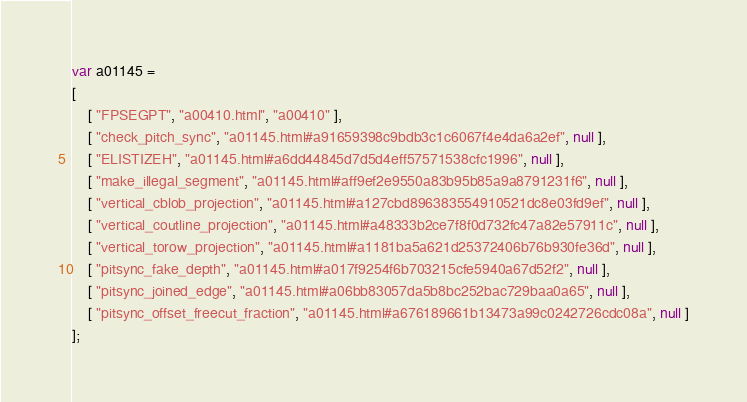Convert code to text. <code><loc_0><loc_0><loc_500><loc_500><_JavaScript_>var a01145 =
[
    [ "FPSEGPT", "a00410.html", "a00410" ],
    [ "check_pitch_sync", "a01145.html#a91659398c9bdb3c1c6067f4e4da6a2ef", null ],
    [ "ELISTIZEH", "a01145.html#a6dd44845d7d5d4eff57571538cfc1996", null ],
    [ "make_illegal_segment", "a01145.html#aff9ef2e9550a83b95b85a9a8791231f6", null ],
    [ "vertical_cblob_projection", "a01145.html#a127cbd896383554910521dc8e03fd9ef", null ],
    [ "vertical_coutline_projection", "a01145.html#a48333b2ce7f8f0d732fc47a82e57911c", null ],
    [ "vertical_torow_projection", "a01145.html#a1181ba5a621d25372406b76b930fe36d", null ],
    [ "pitsync_fake_depth", "a01145.html#a017f9254f6b703215cfe5940a67d52f2", null ],
    [ "pitsync_joined_edge", "a01145.html#a06bb83057da5b8bc252bac729baa0a65", null ],
    [ "pitsync_offset_freecut_fraction", "a01145.html#a676189661b13473a99c0242726cdc08a", null ]
];</code> 